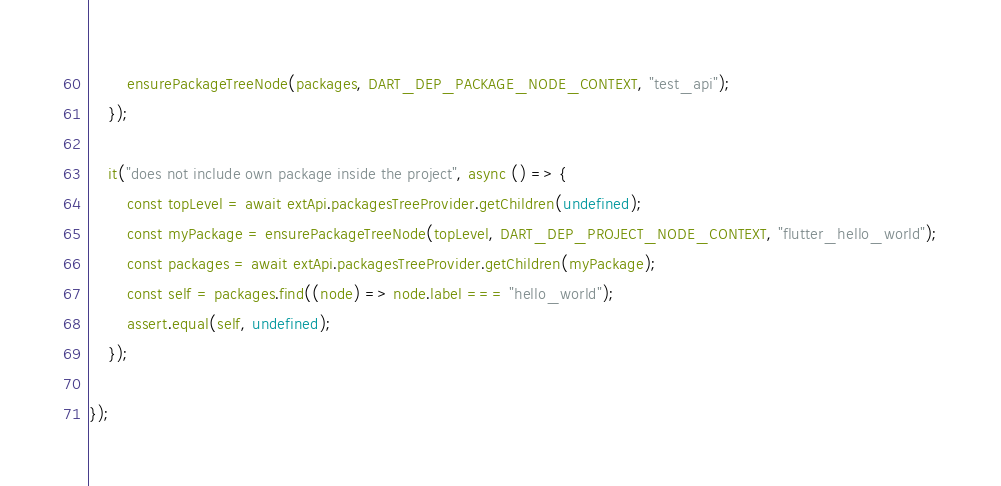<code> <loc_0><loc_0><loc_500><loc_500><_TypeScript_>		ensurePackageTreeNode(packages, DART_DEP_PACKAGE_NODE_CONTEXT, "test_api");
	});

	it("does not include own package inside the project", async () => {
		const topLevel = await extApi.packagesTreeProvider.getChildren(undefined);
		const myPackage = ensurePackageTreeNode(topLevel, DART_DEP_PROJECT_NODE_CONTEXT, "flutter_hello_world");
		const packages = await extApi.packagesTreeProvider.getChildren(myPackage);
		const self = packages.find((node) => node.label === "hello_world");
		assert.equal(self, undefined);
	});

});
</code> 